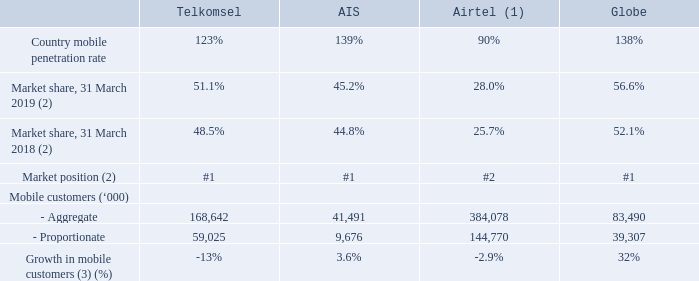Notes:
(1) Mobile penetration rate, market share and market position pertained to India market only.
(2) Based on number of mobile customers.
(3) Compared against 31 March 2018 and based on aggregate mobile customers.
Which market does the information reflect for Airtel? India. What is the market position of AIS? #1. What is the % growth of mobile customers for AIS? 3.6%. Which associate had the best % growth in mobile customers? 32% > 3.6% > -2.9% > -13%
Answer: globe. Which associate has the worst market position? #2 is worse than #1.
Answer: airtel. Which associate had the biggest change in market share from 2018 to 2019? (56.6 - 52.1) % > (51.1 - 48.5) % > (28.0 - 25.7) % > (45.2 - 44.8) %
Answer: globe. 